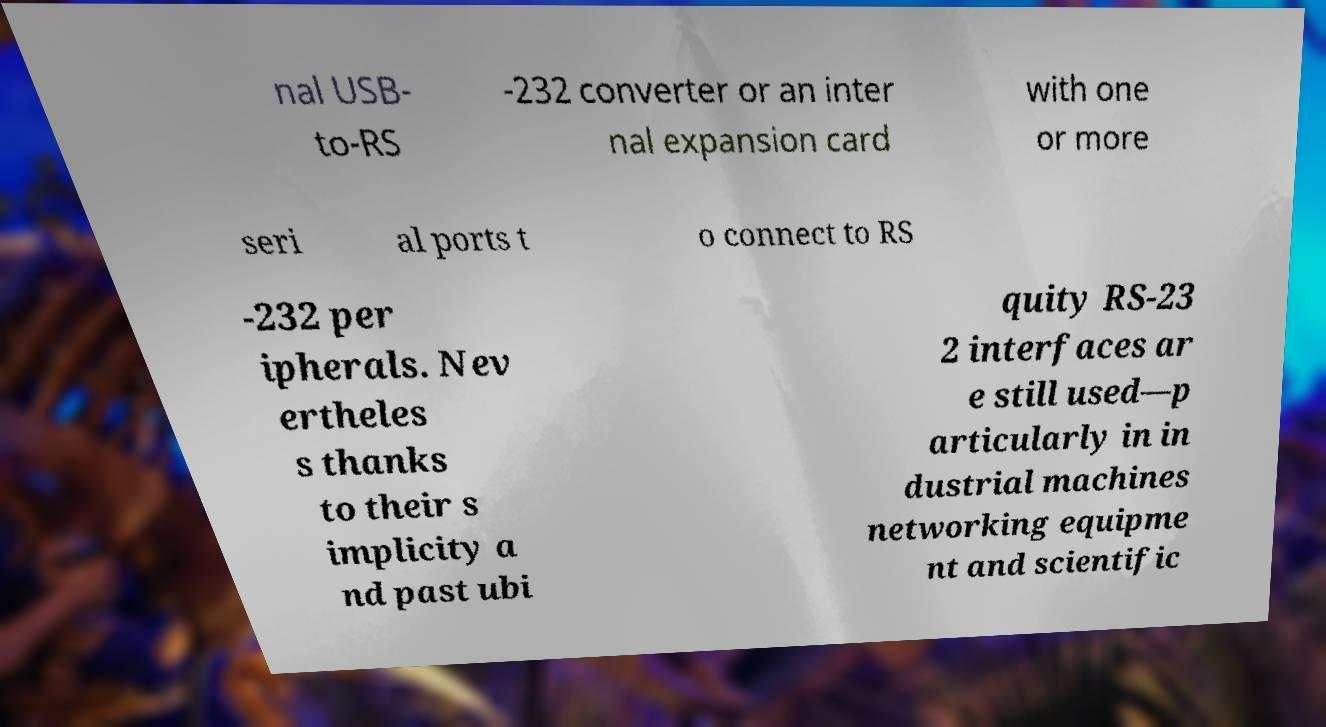Please read and relay the text visible in this image. What does it say? nal USB- to-RS -232 converter or an inter nal expansion card with one or more seri al ports t o connect to RS -232 per ipherals. Nev ertheles s thanks to their s implicity a nd past ubi quity RS-23 2 interfaces ar e still used—p articularly in in dustrial machines networking equipme nt and scientific 